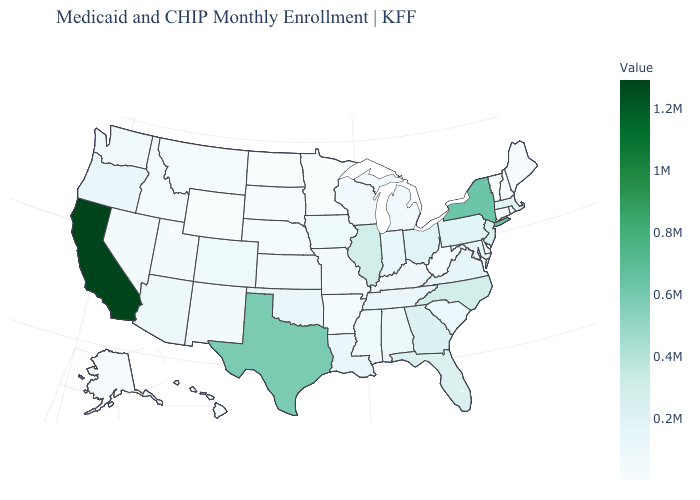Which states have the lowest value in the USA?
Quick response, please. Minnesota. Among the states that border Iowa , does Minnesota have the lowest value?
Answer briefly. Yes. Which states hav the highest value in the South?
Be succinct. Texas. Among the states that border California , does Arizona have the highest value?
Keep it brief. No. Does North Dakota have the highest value in the USA?
Write a very short answer. No. Among the states that border New York , which have the highest value?
Give a very brief answer. New Jersey. 